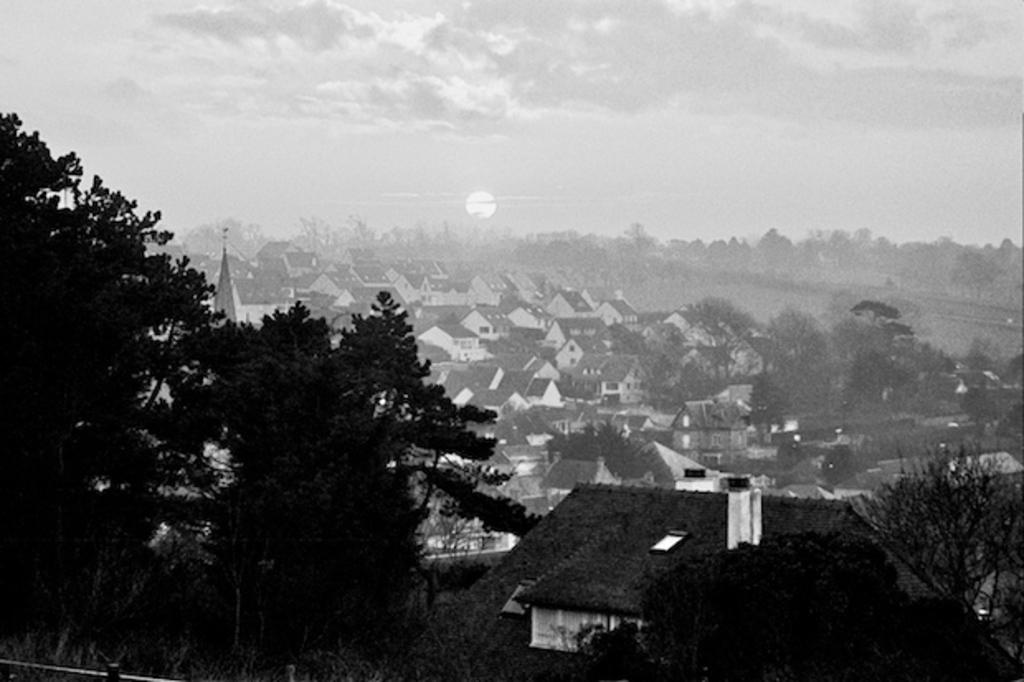What is the color scheme of the image? The image is black and white. What type of vegetation can be seen in the image? There are trees and plants in the image. What type of structure is present in the image? There is a house in the image. What can be seen in the background of the image? In the background, there are multiple houses and more trees. What is the condition of the sky in the background? The sky in the background is cloudy. What type of brass instrument is being played by the stranger in the image? There is no brass instrument or stranger present in the image. 